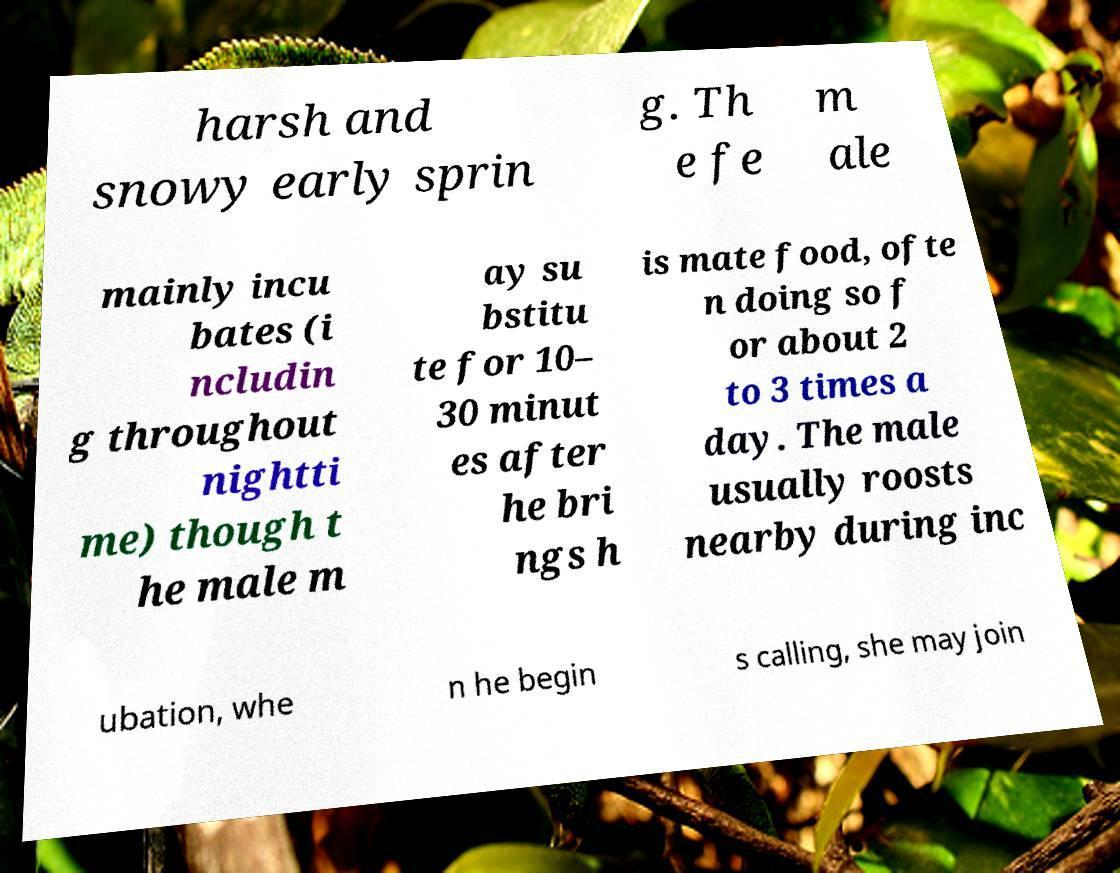There's text embedded in this image that I need extracted. Can you transcribe it verbatim? harsh and snowy early sprin g. Th e fe m ale mainly incu bates (i ncludin g throughout nightti me) though t he male m ay su bstitu te for 10– 30 minut es after he bri ngs h is mate food, ofte n doing so f or about 2 to 3 times a day. The male usually roosts nearby during inc ubation, whe n he begin s calling, she may join 